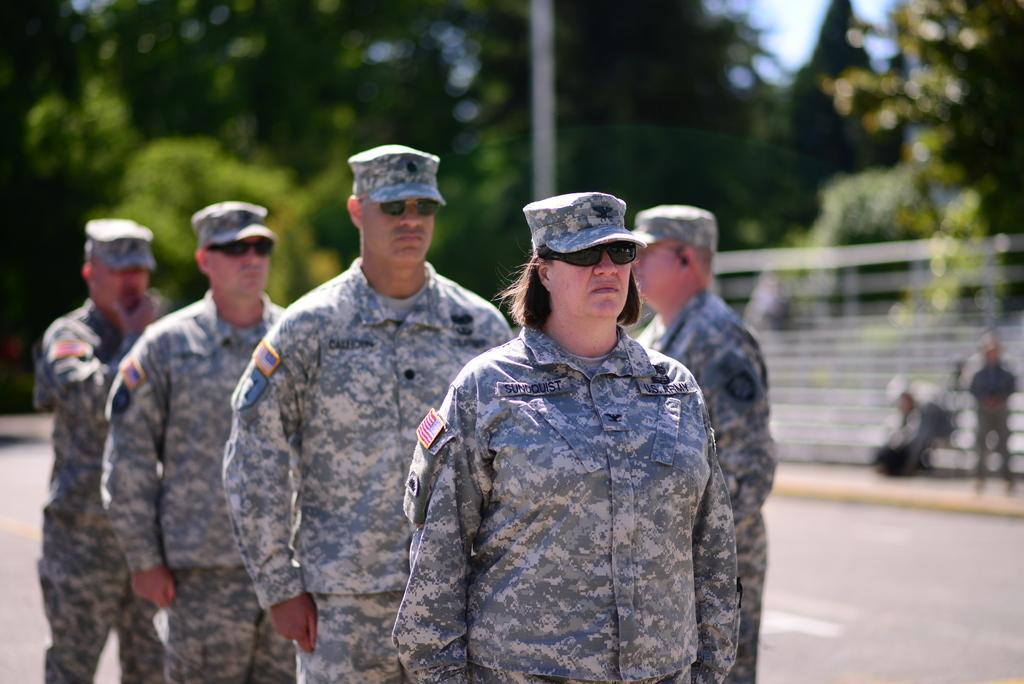In one or two sentences, can you explain what this image depicts? In this image there are soldiers standing on a road, in the background there are trees and it is blurred. 